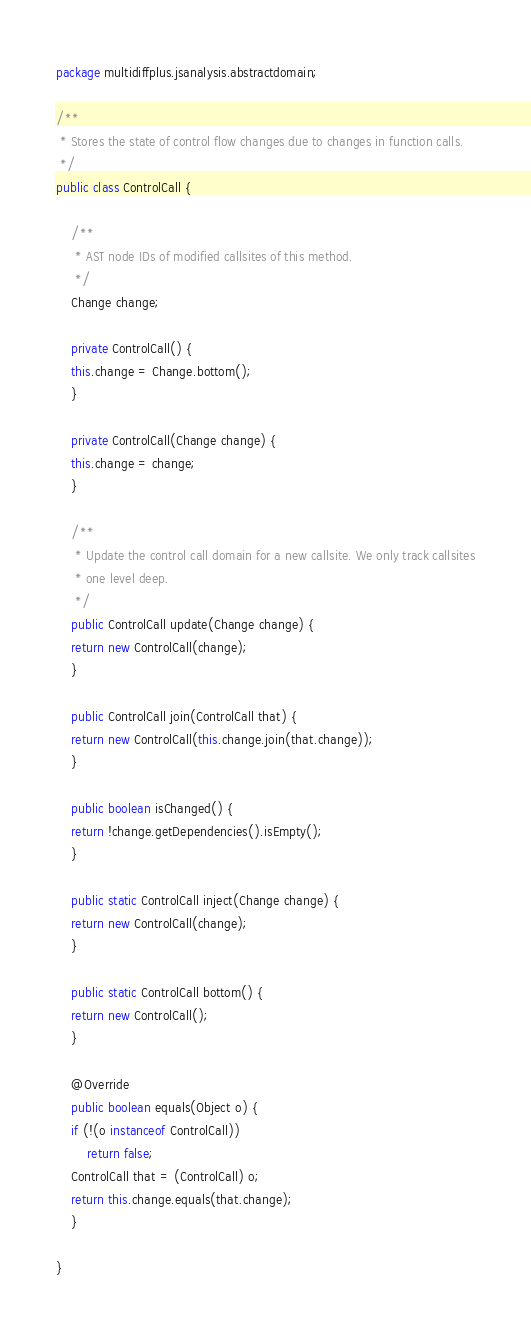<code> <loc_0><loc_0><loc_500><loc_500><_Java_>package multidiffplus.jsanalysis.abstractdomain;

/**
 * Stores the state of control flow changes due to changes in function calls.
 */
public class ControlCall {

    /**
     * AST node IDs of modified callsites of this method.
     */
    Change change;

    private ControlCall() {
	this.change = Change.bottom();
    }

    private ControlCall(Change change) {
	this.change = change;
    }

    /**
     * Update the control call domain for a new callsite. We only track callsites
     * one level deep.
     */
    public ControlCall update(Change change) {
	return new ControlCall(change);
    }

    public ControlCall join(ControlCall that) {
	return new ControlCall(this.change.join(that.change));
    }

    public boolean isChanged() {
	return !change.getDependencies().isEmpty();
    }

    public static ControlCall inject(Change change) {
	return new ControlCall(change);
    }

    public static ControlCall bottom() {
	return new ControlCall();
    }

    @Override
    public boolean equals(Object o) {
	if (!(o instanceof ControlCall))
	    return false;
	ControlCall that = (ControlCall) o;
	return this.change.equals(that.change);
    }

}
</code> 